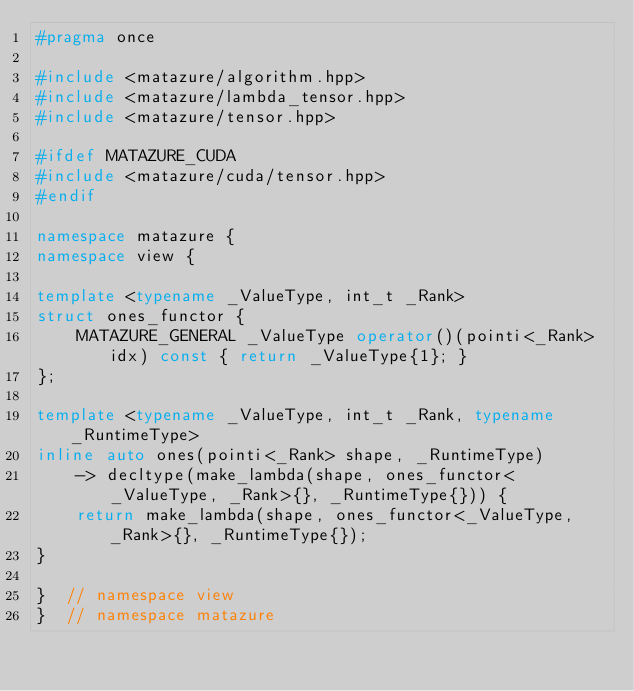<code> <loc_0><loc_0><loc_500><loc_500><_C++_>#pragma once

#include <matazure/algorithm.hpp>
#include <matazure/lambda_tensor.hpp>
#include <matazure/tensor.hpp>

#ifdef MATAZURE_CUDA
#include <matazure/cuda/tensor.hpp>
#endif

namespace matazure {
namespace view {

template <typename _ValueType, int_t _Rank>
struct ones_functor {
    MATAZURE_GENERAL _ValueType operator()(pointi<_Rank> idx) const { return _ValueType{1}; }
};

template <typename _ValueType, int_t _Rank, typename _RuntimeType>
inline auto ones(pointi<_Rank> shape, _RuntimeType)
    -> decltype(make_lambda(shape, ones_functor<_ValueType, _Rank>{}, _RuntimeType{})) {
    return make_lambda(shape, ones_functor<_ValueType, _Rank>{}, _RuntimeType{});
}

}  // namespace view
}  // namespace matazure
</code> 